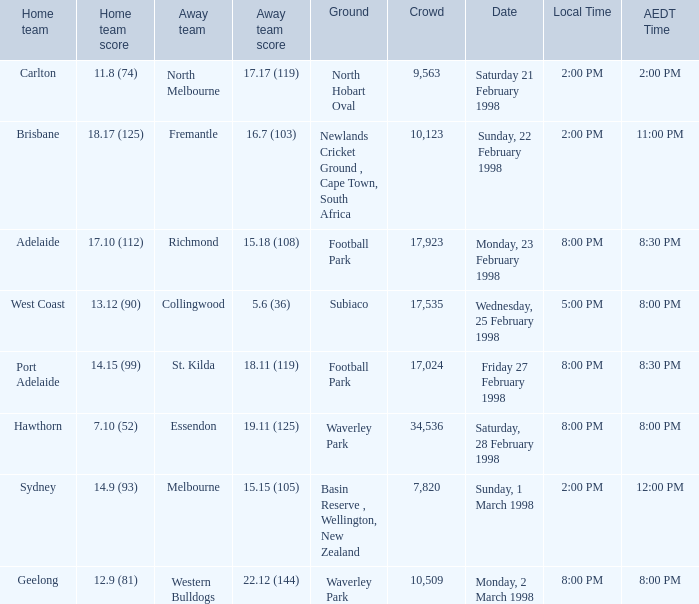Which home team score has an aedt time of 11:00 pm? 18.17 (125). 